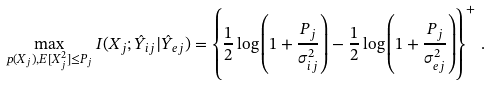Convert formula to latex. <formula><loc_0><loc_0><loc_500><loc_500>\max _ { p ( X _ { j } ) , E [ X _ { j } ^ { 2 } ] \leq P _ { j } } I ( X _ { j } ; \hat { Y } _ { i j } | \hat { Y } _ { e j } ) = \left \{ \frac { 1 } { 2 } \log \left ( 1 + \frac { P _ { j } } { \sigma _ { i j } ^ { 2 } } \right ) - \frac { 1 } { 2 } \log \left ( 1 + \frac { P _ { j } } { \sigma _ { e j } ^ { 2 } } \right ) \right \} ^ { + } \, .</formula> 